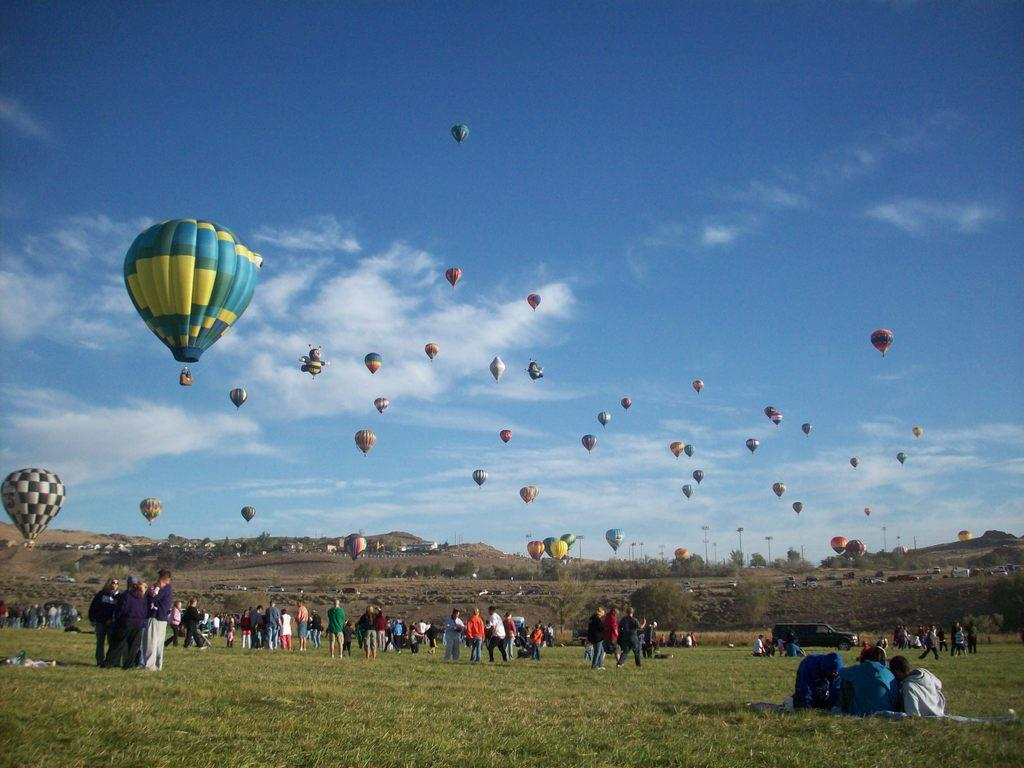What is the location of the people in the image? The people are on the grass in the image. What can be seen in the sky in the image? There are parachutes in the air in the image. What type of screw is being used to hold the clock in the image? There is no clock or screw present in the image; it features people on the grass and parachutes in the air. 